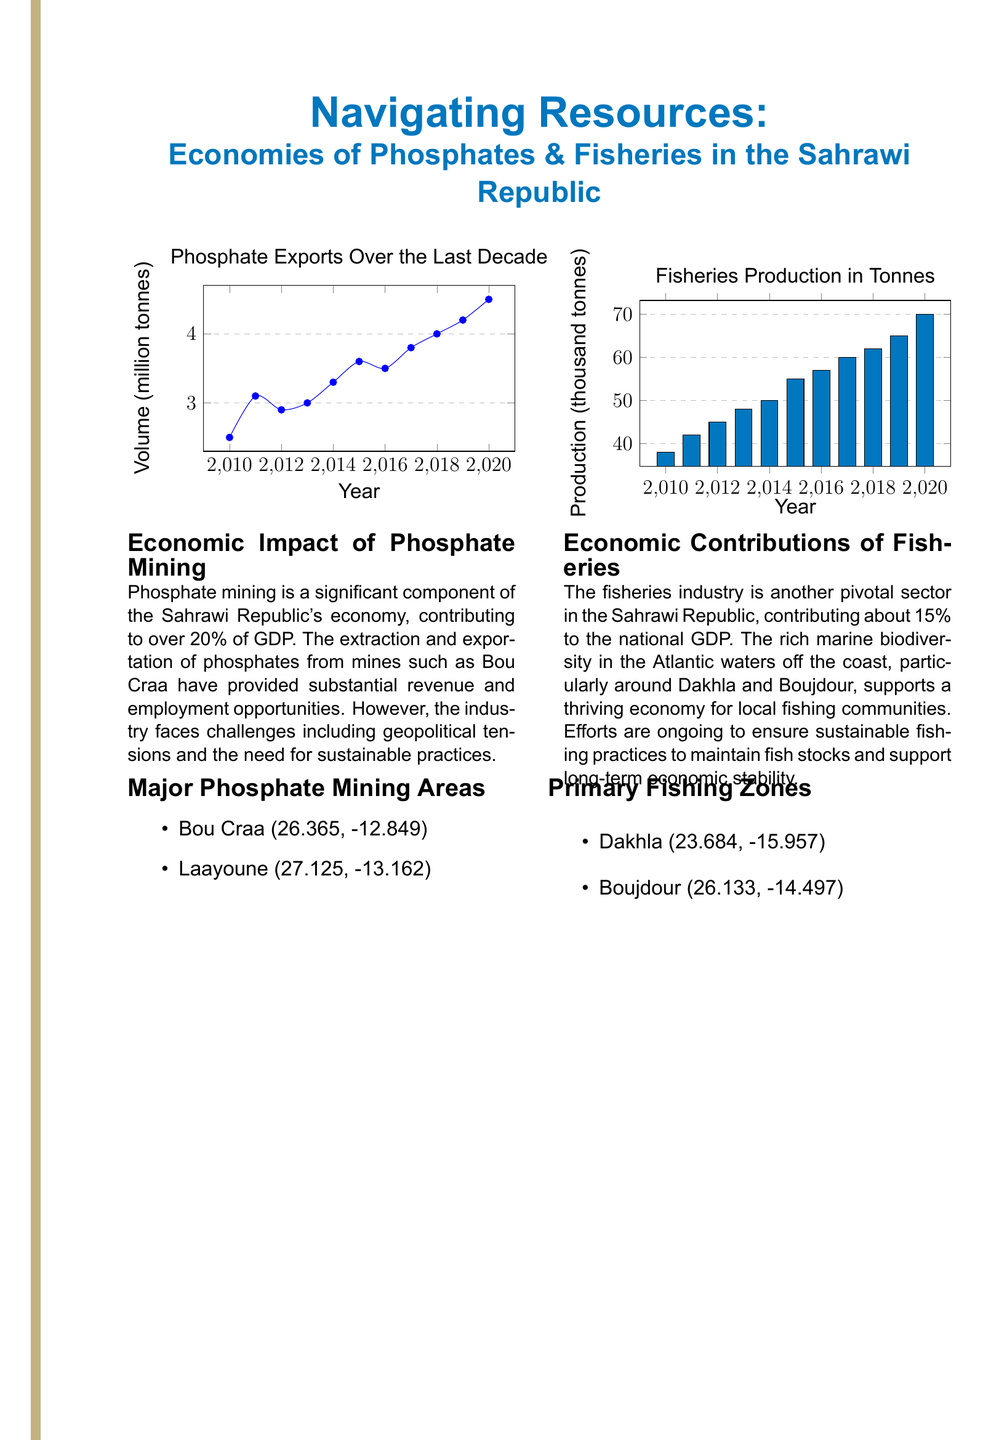what is the title of the document? The title is prominently displayed at the top of the document layout.
Answer: Navigating Resources: Economies of Phosphates & Fisheries in the Sahrawi Republic what is the phosphate volume exported in 2020? The specific year and its corresponding volume is shown in the phosphate exports chart.
Answer: 4.5 million tonnes what percentage does phosphate mining contribute to the GDP? The document specifies the economic impact of phosphate mining in terms of its contribution to GDP.
Answer: 20% what is the production of fisheries in 2015? The fisheries production chart provides the value for that particular year.
Answer: 55 thousand tonnes which region is listed as a primary fishing zone? The document mentions specific regions related to fishing activities under fishing zones.
Answer: Dakhla how many years does the phosphate export data cover? The chart indicates a starting year and an ending year, so a simple subtraction can determine the range covered.
Answer: 11 years what is the economic contribution of the fisheries industry? The document specifies the contribution of the fisheries industry to the national GDP.
Answer: 15% name one major phosphate mining area. The document lists specific sites where phosphate mining occurs.
Answer: Bou Craa what is the trend of phosphate exports from 2010 to 2020? Analysis of the chart shows if the values are increasing, decreasing, or remaining stable over the years.
Answer: Increasing which color represents fisheries production in the chart? The chart utilizes a specific color to differentiate the fisheries production data visually.
Answer: Ocean blue 